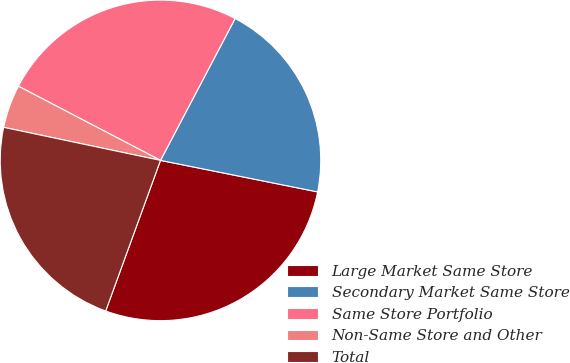<chart> <loc_0><loc_0><loc_500><loc_500><pie_chart><fcel>Large Market Same Store<fcel>Secondary Market Same Store<fcel>Same Store Portfolio<fcel>Non-Same Store and Other<fcel>Total<nl><fcel>27.4%<fcel>20.44%<fcel>25.05%<fcel>4.35%<fcel>22.75%<nl></chart> 